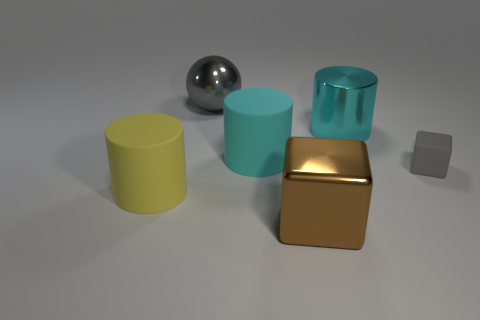How would you describe the arrangement and composition of these objects? The arrangement is simplistic yet visually balanced. The objects are spaced in a manner that creates an interesting depth, with varying shapes and sizes contributing to a harmonious composition. 